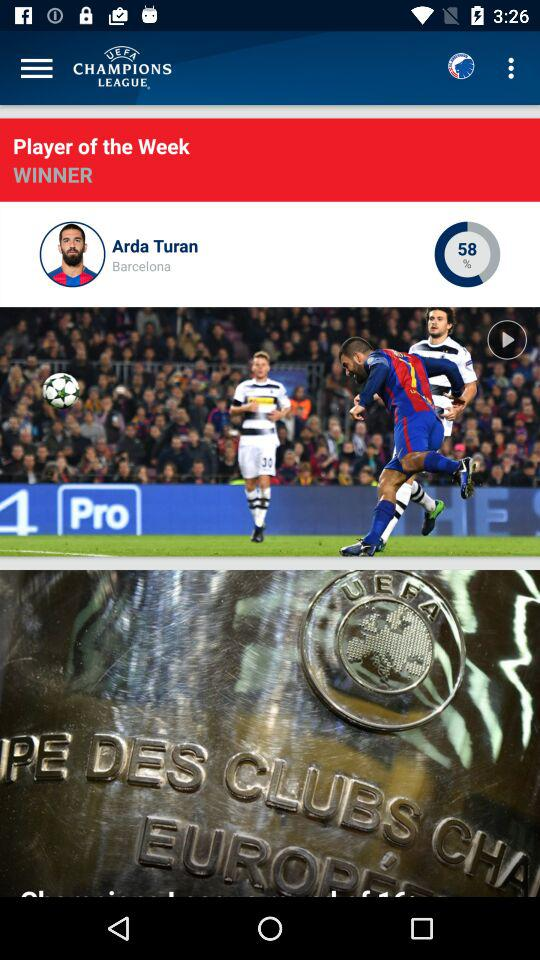What's the club name for which Arda Turan plays? The club name for which Arda Turan plays is "Barcelona". 